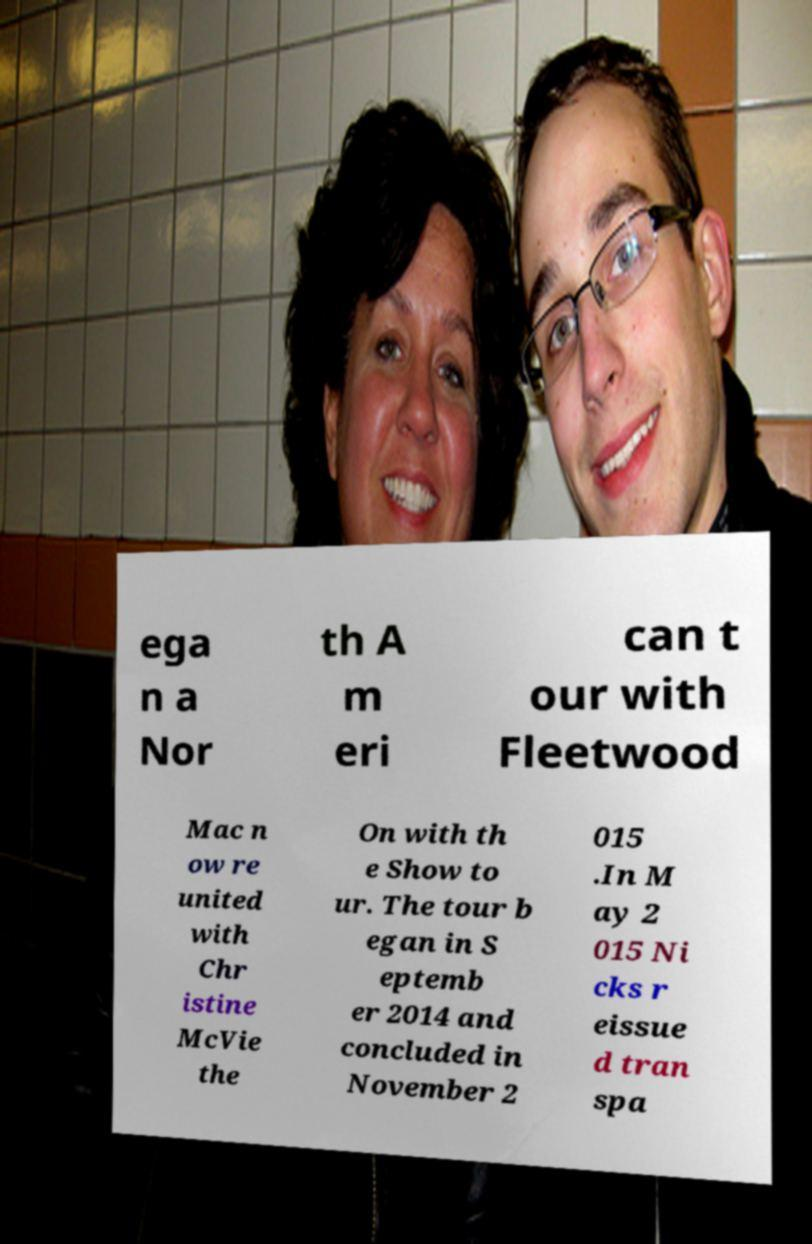Please identify and transcribe the text found in this image. ega n a Nor th A m eri can t our with Fleetwood Mac n ow re united with Chr istine McVie the On with th e Show to ur. The tour b egan in S eptemb er 2014 and concluded in November 2 015 .In M ay 2 015 Ni cks r eissue d tran spa 